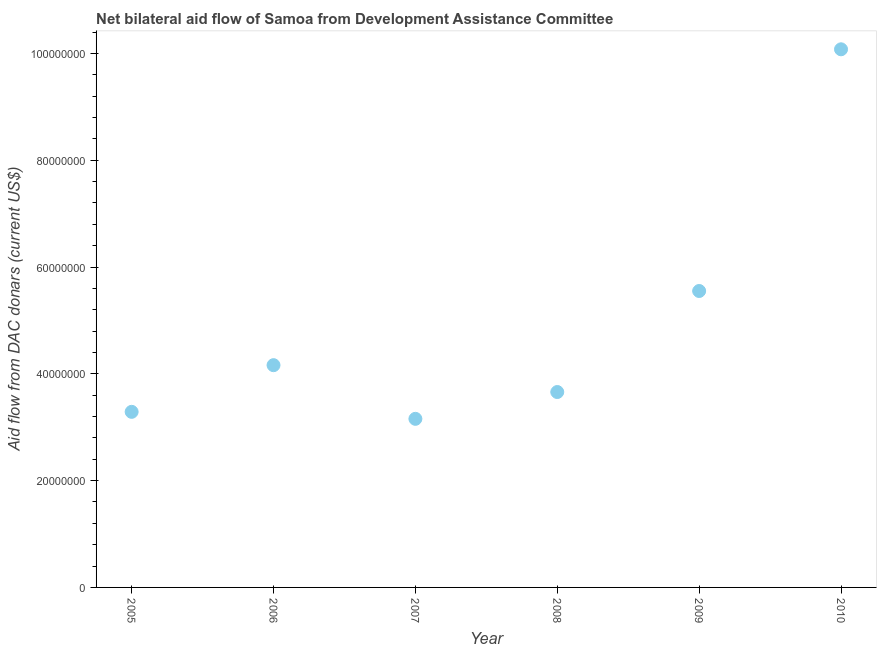What is the net bilateral aid flows from dac donors in 2010?
Your answer should be very brief. 1.01e+08. Across all years, what is the maximum net bilateral aid flows from dac donors?
Ensure brevity in your answer.  1.01e+08. Across all years, what is the minimum net bilateral aid flows from dac donors?
Provide a short and direct response. 3.16e+07. In which year was the net bilateral aid flows from dac donors maximum?
Provide a short and direct response. 2010. What is the sum of the net bilateral aid flows from dac donors?
Offer a terse response. 2.99e+08. What is the difference between the net bilateral aid flows from dac donors in 2007 and 2009?
Give a very brief answer. -2.39e+07. What is the average net bilateral aid flows from dac donors per year?
Keep it short and to the point. 4.98e+07. What is the median net bilateral aid flows from dac donors?
Keep it short and to the point. 3.91e+07. Do a majority of the years between 2005 and 2008 (inclusive) have net bilateral aid flows from dac donors greater than 28000000 US$?
Your answer should be very brief. Yes. What is the ratio of the net bilateral aid flows from dac donors in 2006 to that in 2007?
Provide a short and direct response. 1.32. Is the difference between the net bilateral aid flows from dac donors in 2005 and 2007 greater than the difference between any two years?
Offer a terse response. No. What is the difference between the highest and the second highest net bilateral aid flows from dac donors?
Provide a succinct answer. 4.53e+07. Is the sum of the net bilateral aid flows from dac donors in 2006 and 2010 greater than the maximum net bilateral aid flows from dac donors across all years?
Provide a short and direct response. Yes. What is the difference between the highest and the lowest net bilateral aid flows from dac donors?
Give a very brief answer. 6.92e+07. Does the net bilateral aid flows from dac donors monotonically increase over the years?
Make the answer very short. No. Are the values on the major ticks of Y-axis written in scientific E-notation?
Your response must be concise. No. Does the graph contain any zero values?
Provide a short and direct response. No. Does the graph contain grids?
Your answer should be compact. No. What is the title of the graph?
Your answer should be compact. Net bilateral aid flow of Samoa from Development Assistance Committee. What is the label or title of the Y-axis?
Ensure brevity in your answer.  Aid flow from DAC donars (current US$). What is the Aid flow from DAC donars (current US$) in 2005?
Offer a very short reply. 3.29e+07. What is the Aid flow from DAC donars (current US$) in 2006?
Keep it short and to the point. 4.16e+07. What is the Aid flow from DAC donars (current US$) in 2007?
Provide a short and direct response. 3.16e+07. What is the Aid flow from DAC donars (current US$) in 2008?
Your response must be concise. 3.66e+07. What is the Aid flow from DAC donars (current US$) in 2009?
Provide a short and direct response. 5.55e+07. What is the Aid flow from DAC donars (current US$) in 2010?
Make the answer very short. 1.01e+08. What is the difference between the Aid flow from DAC donars (current US$) in 2005 and 2006?
Offer a terse response. -8.74e+06. What is the difference between the Aid flow from DAC donars (current US$) in 2005 and 2007?
Provide a short and direct response. 1.31e+06. What is the difference between the Aid flow from DAC donars (current US$) in 2005 and 2008?
Provide a succinct answer. -3.71e+06. What is the difference between the Aid flow from DAC donars (current US$) in 2005 and 2009?
Provide a short and direct response. -2.26e+07. What is the difference between the Aid flow from DAC donars (current US$) in 2005 and 2010?
Your answer should be compact. -6.79e+07. What is the difference between the Aid flow from DAC donars (current US$) in 2006 and 2007?
Keep it short and to the point. 1.00e+07. What is the difference between the Aid flow from DAC donars (current US$) in 2006 and 2008?
Offer a very short reply. 5.03e+06. What is the difference between the Aid flow from DAC donars (current US$) in 2006 and 2009?
Your answer should be very brief. -1.39e+07. What is the difference between the Aid flow from DAC donars (current US$) in 2006 and 2010?
Your answer should be very brief. -5.92e+07. What is the difference between the Aid flow from DAC donars (current US$) in 2007 and 2008?
Offer a terse response. -5.02e+06. What is the difference between the Aid flow from DAC donars (current US$) in 2007 and 2009?
Your response must be concise. -2.39e+07. What is the difference between the Aid flow from DAC donars (current US$) in 2007 and 2010?
Provide a succinct answer. -6.92e+07. What is the difference between the Aid flow from DAC donars (current US$) in 2008 and 2009?
Your response must be concise. -1.89e+07. What is the difference between the Aid flow from DAC donars (current US$) in 2008 and 2010?
Give a very brief answer. -6.42e+07. What is the difference between the Aid flow from DAC donars (current US$) in 2009 and 2010?
Offer a very short reply. -4.53e+07. What is the ratio of the Aid flow from DAC donars (current US$) in 2005 to that in 2006?
Give a very brief answer. 0.79. What is the ratio of the Aid flow from DAC donars (current US$) in 2005 to that in 2007?
Offer a terse response. 1.04. What is the ratio of the Aid flow from DAC donars (current US$) in 2005 to that in 2008?
Your response must be concise. 0.9. What is the ratio of the Aid flow from DAC donars (current US$) in 2005 to that in 2009?
Provide a short and direct response. 0.59. What is the ratio of the Aid flow from DAC donars (current US$) in 2005 to that in 2010?
Offer a very short reply. 0.33. What is the ratio of the Aid flow from DAC donars (current US$) in 2006 to that in 2007?
Your answer should be very brief. 1.32. What is the ratio of the Aid flow from DAC donars (current US$) in 2006 to that in 2008?
Make the answer very short. 1.14. What is the ratio of the Aid flow from DAC donars (current US$) in 2006 to that in 2010?
Provide a succinct answer. 0.41. What is the ratio of the Aid flow from DAC donars (current US$) in 2007 to that in 2008?
Your answer should be very brief. 0.86. What is the ratio of the Aid flow from DAC donars (current US$) in 2007 to that in 2009?
Ensure brevity in your answer.  0.57. What is the ratio of the Aid flow from DAC donars (current US$) in 2007 to that in 2010?
Ensure brevity in your answer.  0.31. What is the ratio of the Aid flow from DAC donars (current US$) in 2008 to that in 2009?
Your response must be concise. 0.66. What is the ratio of the Aid flow from DAC donars (current US$) in 2008 to that in 2010?
Keep it short and to the point. 0.36. What is the ratio of the Aid flow from DAC donars (current US$) in 2009 to that in 2010?
Make the answer very short. 0.55. 